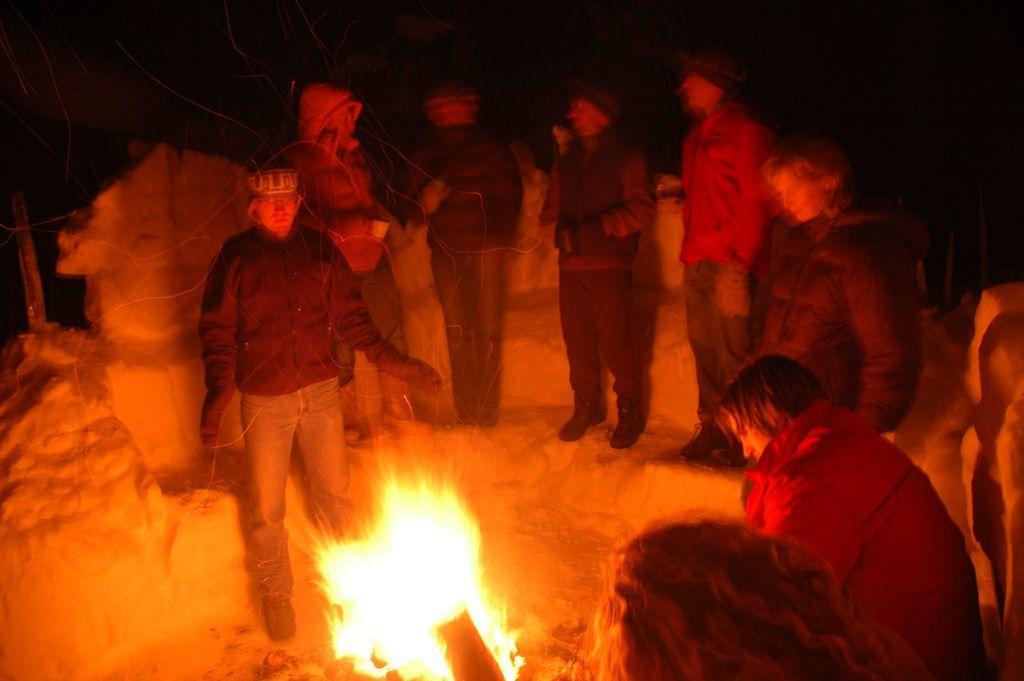Please provide a concise description of this image. In this picture we can see some people are standing, at the bottom there is fire, we can see a dark background. 